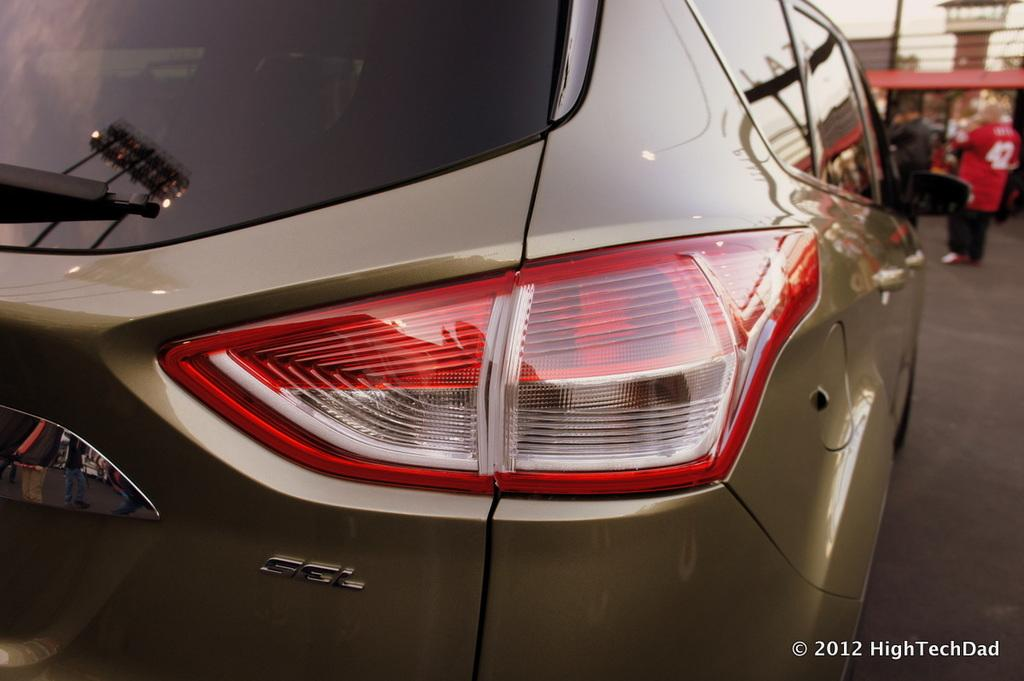What is the main subject of the image? There is a car in the image. Can you describe the person in the image? There is a person on the right side of the image. What can be seen in the background of the image? There is a building in the background of the image. What type of cork can be seen floating in the water near the car? There is no cork or water present in the image; it features a car and a person on the right side, with a building in the background. 